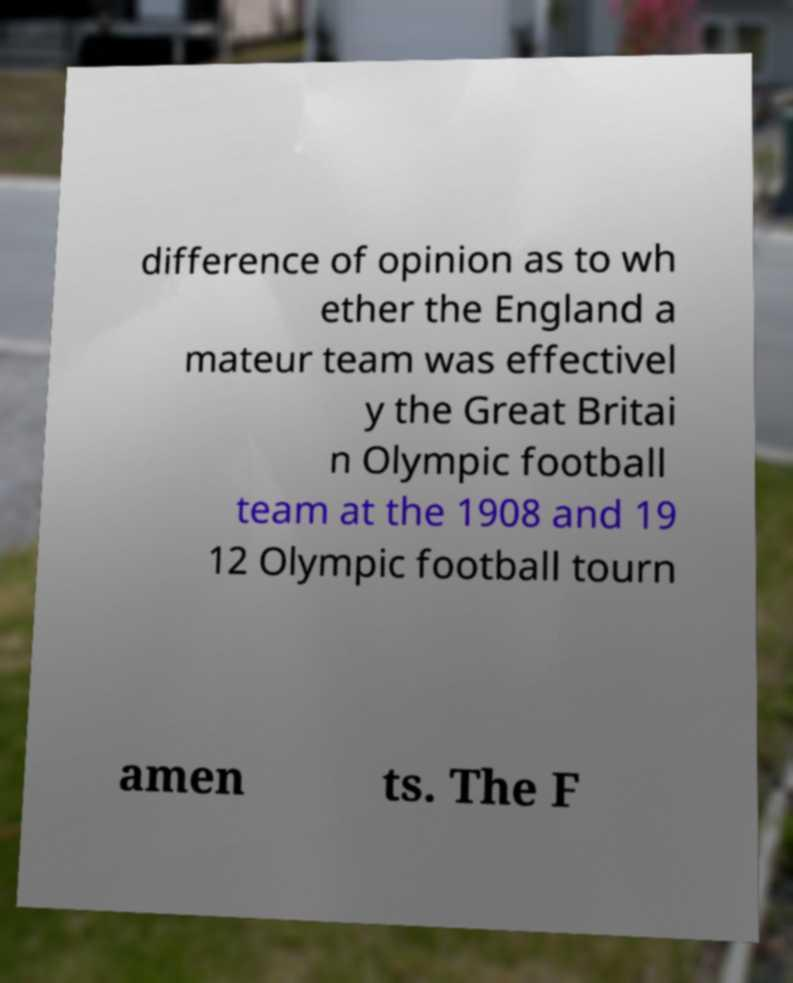Could you extract and type out the text from this image? difference of opinion as to wh ether the England a mateur team was effectivel y the Great Britai n Olympic football team at the 1908 and 19 12 Olympic football tourn amen ts. The F 